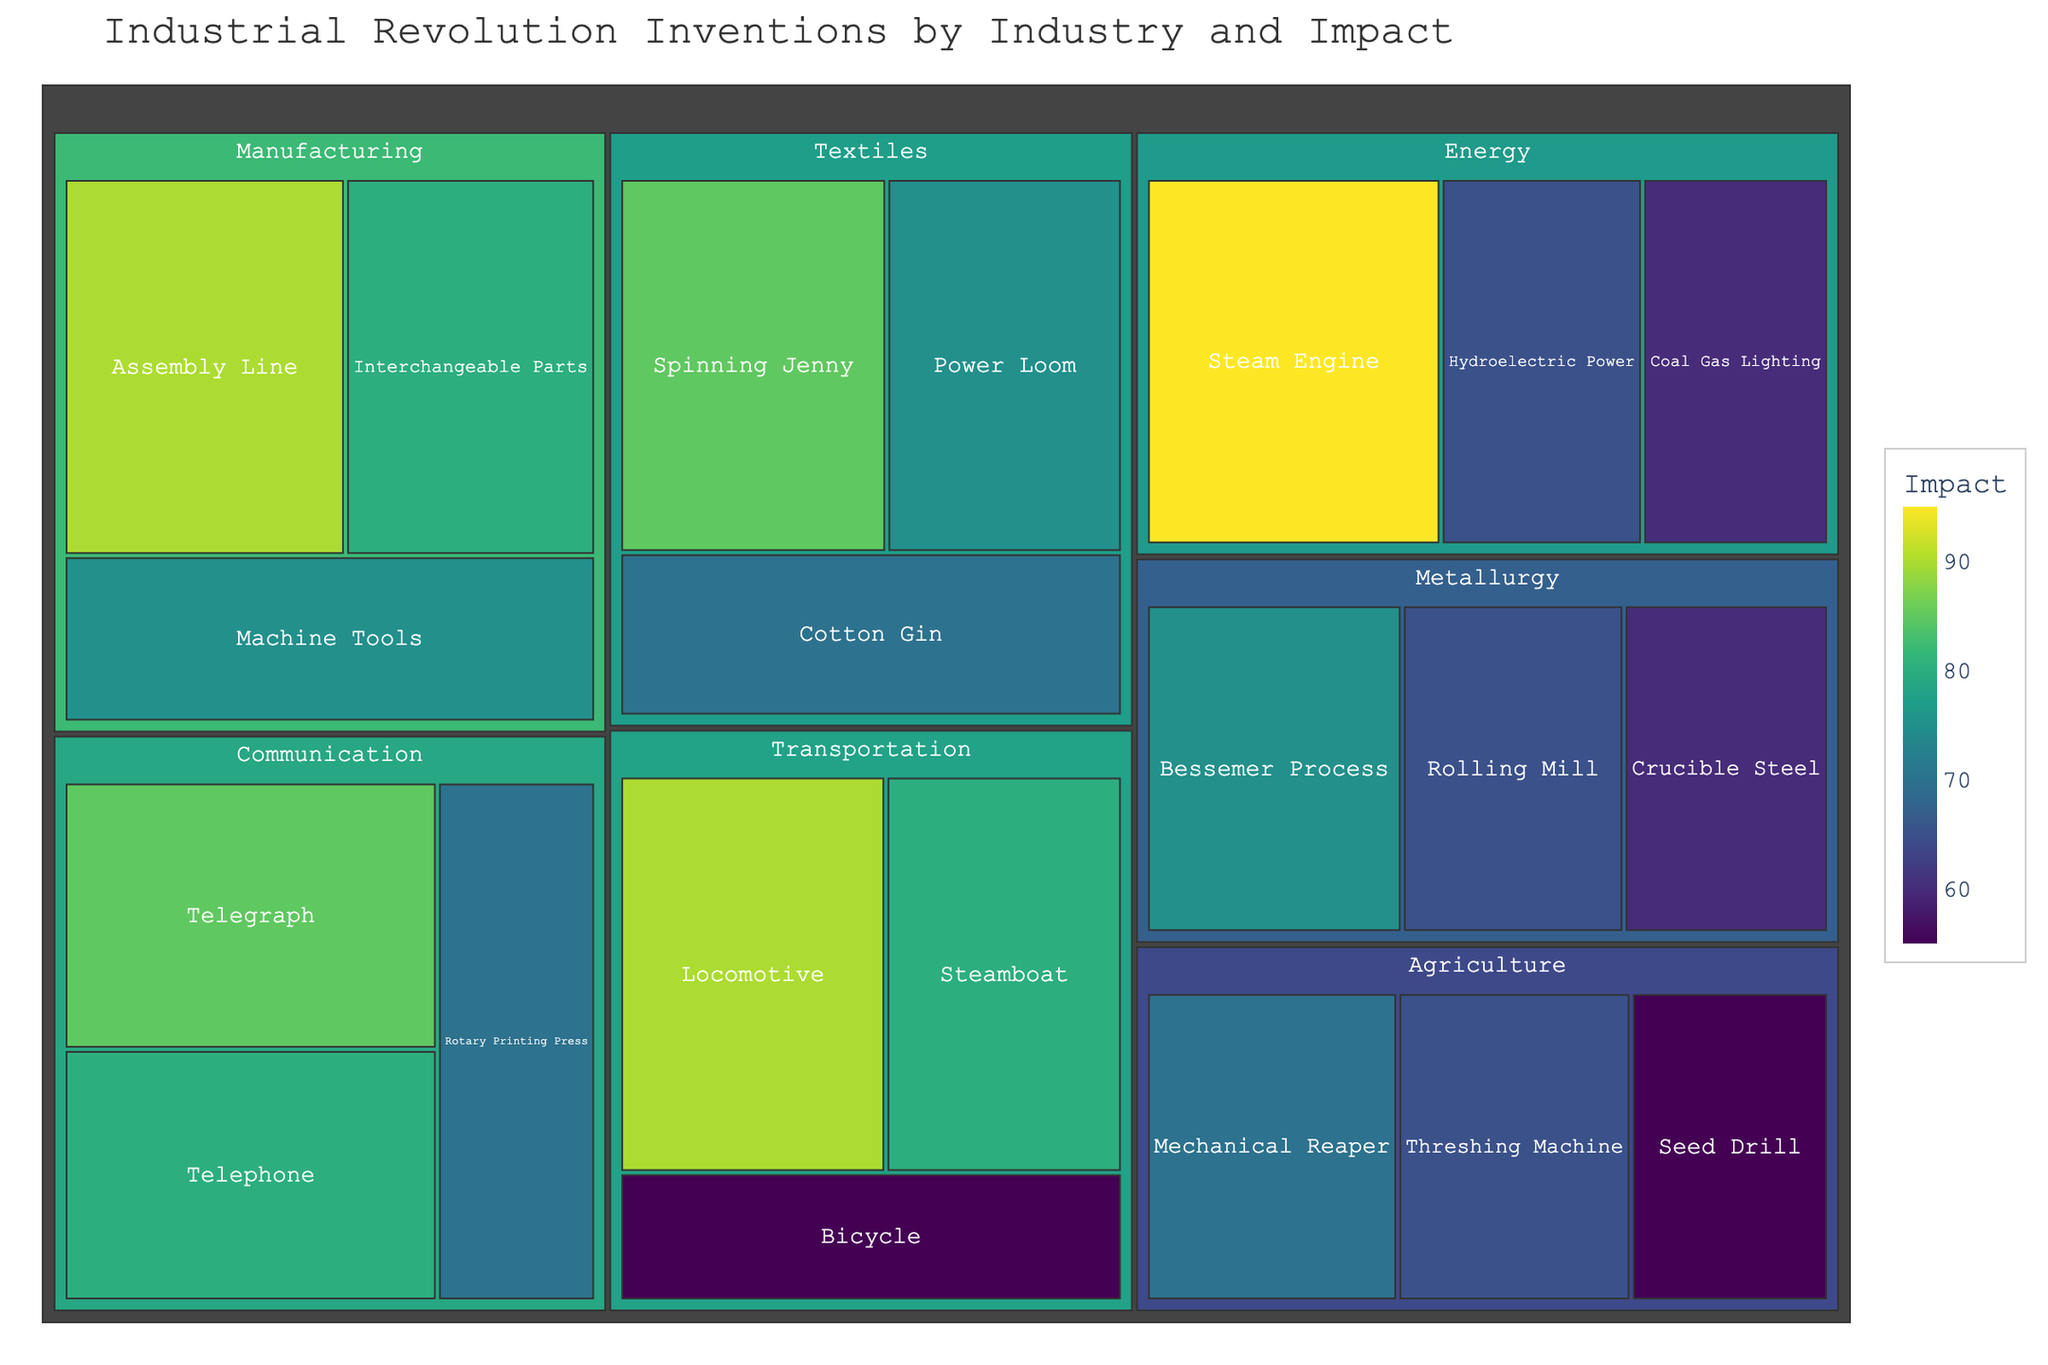what's the title of the treemap? The title of the treemap is displayed at the top of the figure, typically centered and larger in font size for better visibility.
Answer: Industrial Revolution Inventions by Industry and Impact Which invention in the 'Energy' industry has the highest impact? Look under the 'Energy' category and find the invention with the highest numerical value representing impact.
Answer: Steam Engine What’s the average impact of inventions in the 'Textiles' industry? Sum up the impact values for Spinning Jenny (85), Power Loom (75), and Cotton Gin (70), then divide by the number of inventions (3). Calculation: (85 + 75 + 70)/3 = 230/3 = 76.67
Answer: 76.67 Which industry contains the invention with the highest impact? Identify the highest numerical value representing impact across all industries, then locate which category it belongs to.
Answer: Energy How many inventions are there in total in the chart? Count the total number of inventions listed within the treemap across all categories.
Answer: 19 Among the 'Manufacturing' inventions, which has the lower impact: Assembly Line or Interchangeable Parts? Compare the impact values for Assembly Line (90) and Interchangeable Parts (80).
Answer: Interchangeable Parts What is the combined impact of the 'Communication' inventions? Add the impact values of Telegraph (85), Telephone (80), and Rotary Printing Press (70). Calculation: 85 + 80 + 70 = 235
Answer: 235 Which invention in 'Transportation' has a higher impact than the Bicycle? Compare the impact value of the Bicycle (55) with other inventions in the same category, Locomotive (90) and Steamboat (80), to find which is higher.
Answer: Locomotive, Steamboat Which industry has the lowest average impact among its inventions? Calculate the average impact for each industry and compare these averages to find the lowest one. Comparisons: Textiles (76.67), Energy (73.33), Transportation (75), Metallurgy (66.67), Agriculture (63.33), Communication (78.33), Manufacturing (81.67). Agriculture has the lowest.
Answer: Agriculture How does the color gradient represent the impact in the treemap? The color gradient in the treemap (ranging from the light end of the spectrum to the dark) varies based on the impact value, with higher impacts having a more intense or different color.
Answer: Higher impacts have darker colors 